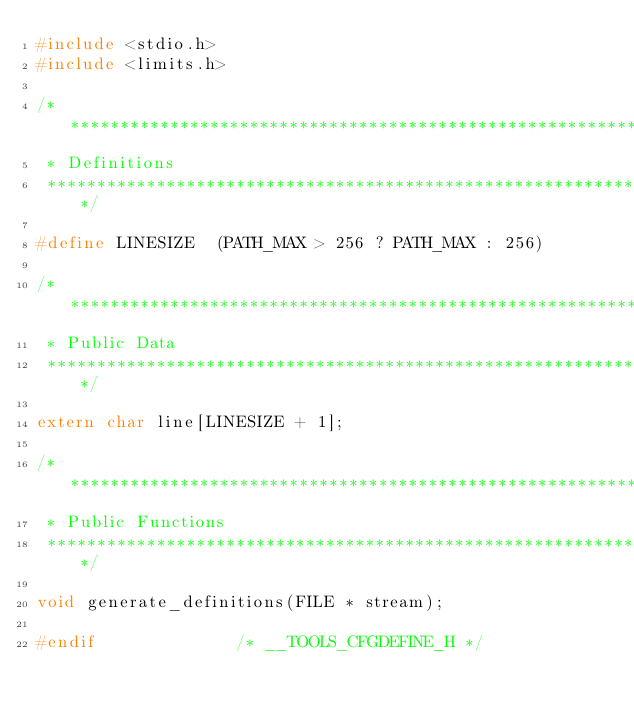Convert code to text. <code><loc_0><loc_0><loc_500><loc_500><_C_>#include <stdio.h>
#include <limits.h>

/****************************************************************************
 * Definitions
 ****************************************************************************/

#define LINESIZE  (PATH_MAX > 256 ? PATH_MAX : 256)

/****************************************************************************
 * Public Data
 ****************************************************************************/

extern char line[LINESIZE + 1];

/****************************************************************************
 * Public Functions
 ****************************************************************************/

void generate_definitions(FILE * stream);

#endif							/* __TOOLS_CFGDEFINE_H */
</code> 